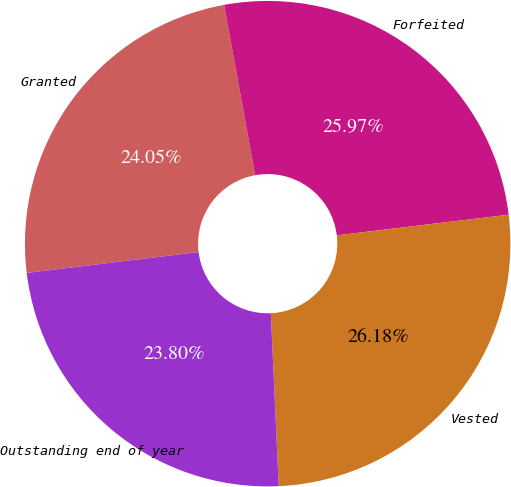<chart> <loc_0><loc_0><loc_500><loc_500><pie_chart><fcel>Granted<fcel>Forfeited<fcel>Vested<fcel>Outstanding end of year<nl><fcel>24.05%<fcel>25.97%<fcel>26.18%<fcel>23.8%<nl></chart> 